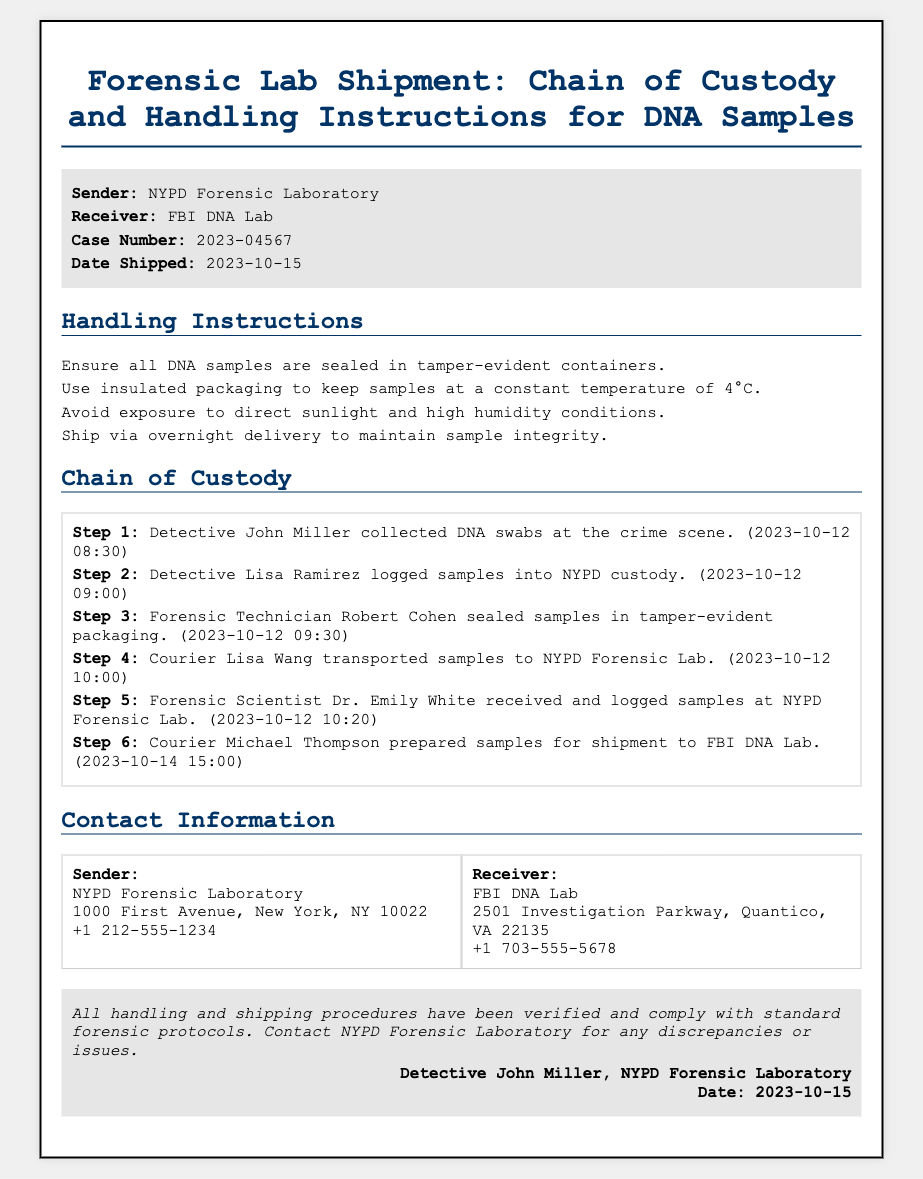What is the sender's name? The sender's name is mentioned in the header of the document, which is NYPD Forensic Laboratory.
Answer: NYPD Forensic Laboratory What is the case number? The case number is provided in the document header, specifically detailing the case being referenced, which is 2023-04567.
Answer: 2023-04567 When was the shipment date? The date shipped is specified in the document header, indicating when the samples were sent, which is 2023-10-15.
Answer: 2023-10-15 What temperature should the samples be kept at? The handling instructions explicitly state that samples should be kept at a constant temperature of 4°C.
Answer: 4°C Who received the samples at the NYPD Forensic Lab? The document outlines the chain of custody, where it states that Forensic Scientist Dr. Emily White received and logged the samples.
Answer: Dr. Emily White Which courier transported the samples to the NYPD Forensic Lab? The chain of custody details that Courier Lisa Wang was responsible for transporting samples to the NYPD Forensic Lab.
Answer: Lisa Wang What are the shipping conditions to maintain sample integrity? The handling instructions highlight that samples should be shipped via overnight delivery to maintain their integrity.
Answer: Overnight delivery What should be avoided in the handling of DNA samples? The handling instructions indicate that exposure to direct sunlight and high humidity conditions should be avoided.
Answer: Direct sunlight and high humidity What does the verification statement in the footer indicate? The verification statement confirms that all handling and shipping procedures have been verified and comply with standard forensic protocols.
Answer: Compliance with standard forensic protocols 